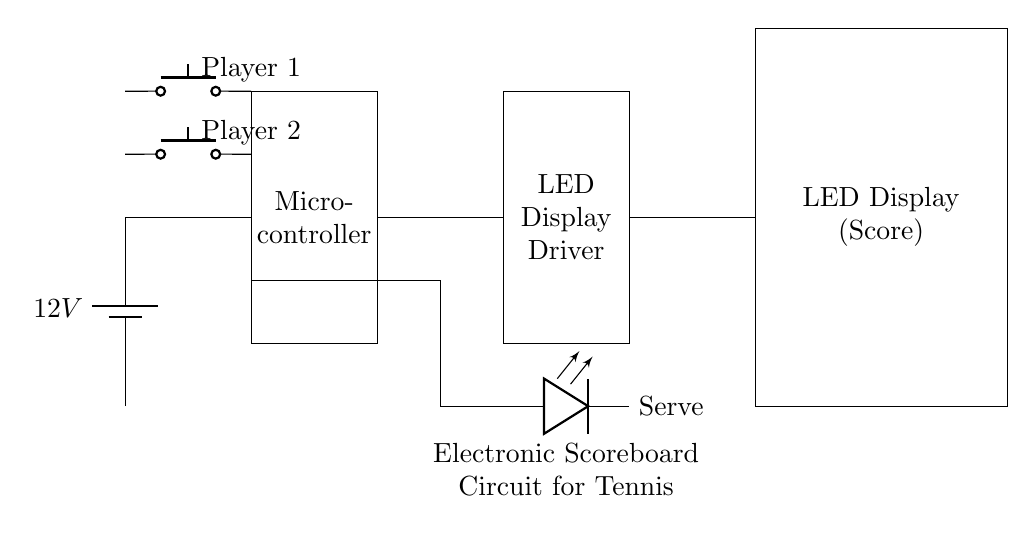What is the voltage of the power supply? The schematic shows a component labeled as a battery with a voltage of 12 volts indicated next to it.
Answer: 12V What does the rectangle labeled “Microcontroller” represent? In the circuit, the rectangular shape with no additional details apart from the label indicates it's a microcontroller, which is the processing unit of the scoreboard.
Answer: Microcontroller How many buttons are present in the circuit? The circuit diagram displays two push buttons identified as "Player 1" and "Player 2". By counting the labeled buttons, we find there are two.
Answer: 2 What is the function of the LED display in this circuit? The circuit labels the display as "LED Display (Score)," which suggests its purpose is to show the score for the tennis match.
Answer: Display Score How is the serve indicator connected in the circuit? The serve indicator is depicted as an LED connected through a path from the microcontroller, which implies that when the microcontroller activates it, the LED lights up to indicate a serve. This connection follows a specific route through the diagram.
Answer: Connected to microcontroller What is the relationship between the Microcontroller and the LED Display Driver? The circuit shows a direct connection line between the microcontroller and the LED display driver, indicating that the microcontroller sends signals to control the display through this driver.
Answer: Direct connection What components control the score input for the players? The circuit has two push buttons labeled directly as "Player 1" and "Player 2", signifying that these buttons are used to input scores for each player.
Answer: Push buttons 